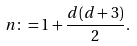Convert formula to latex. <formula><loc_0><loc_0><loc_500><loc_500>n \colon = 1 + \frac { d ( d + 3 ) } { 2 } .</formula> 